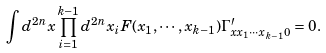<formula> <loc_0><loc_0><loc_500><loc_500>\int d ^ { 2 n } x \prod _ { i = 1 } ^ { k - 1 } d ^ { 2 n } x _ { i } F ( x _ { 1 } , \cdots , x _ { k - 1 } ) \Gamma _ { x x _ { 1 } \cdots x _ { k - 1 } 0 } ^ { \prime } = 0 .</formula> 